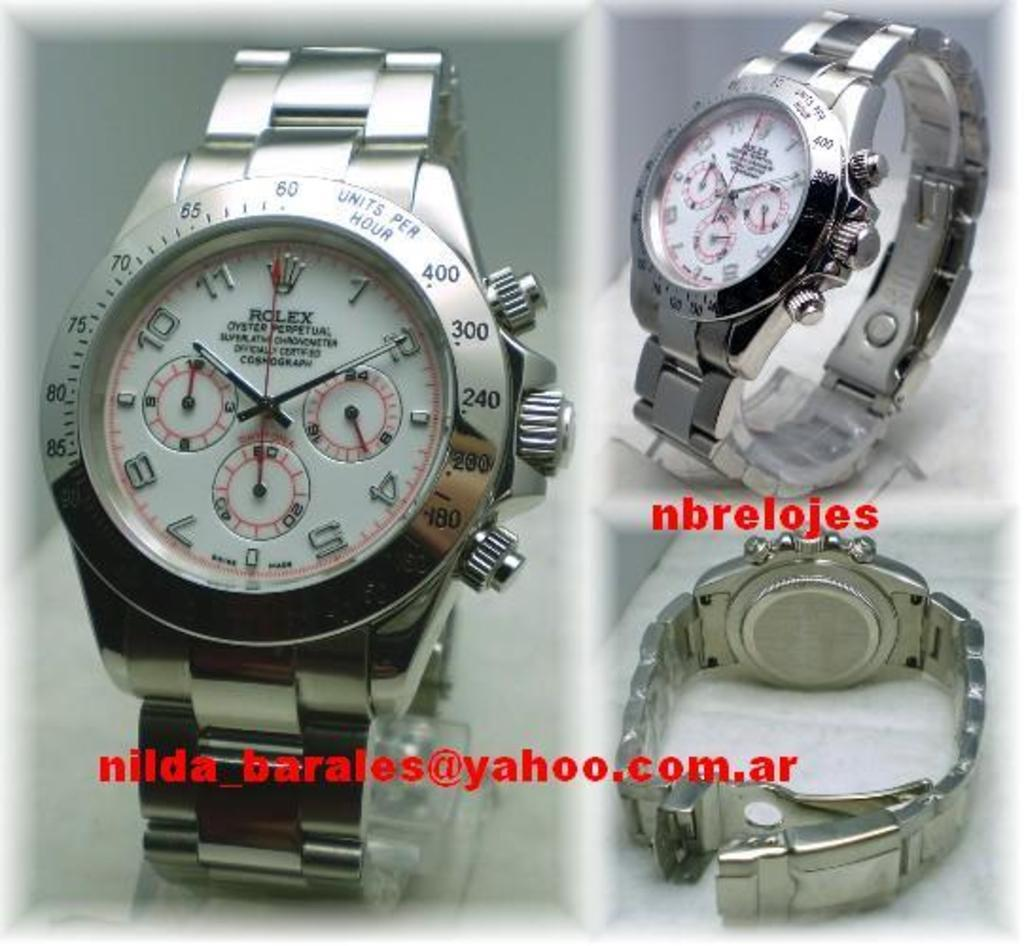<image>
Render a clear and concise summary of the photo. A Rolex advertisement featuring three pictures of a silver watch 